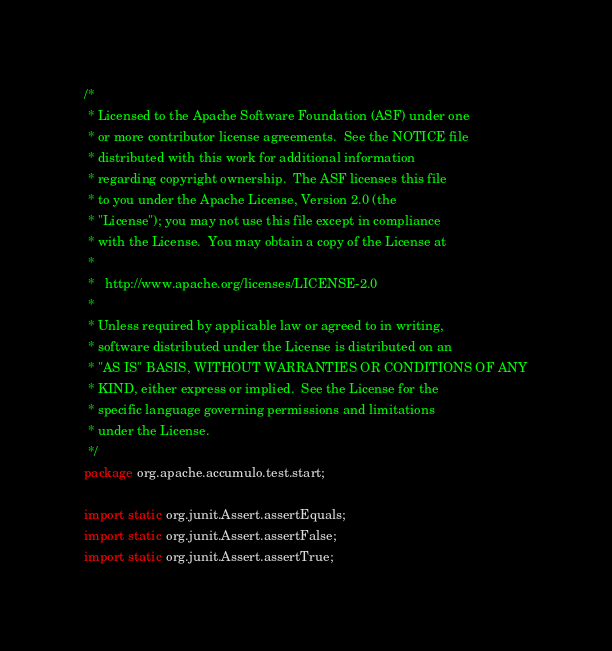<code> <loc_0><loc_0><loc_500><loc_500><_Java_>/*
 * Licensed to the Apache Software Foundation (ASF) under one
 * or more contributor license agreements.  See the NOTICE file
 * distributed with this work for additional information
 * regarding copyright ownership.  The ASF licenses this file
 * to you under the Apache License, Version 2.0 (the
 * "License"); you may not use this file except in compliance
 * with the License.  You may obtain a copy of the License at
 *
 *   http://www.apache.org/licenses/LICENSE-2.0
 *
 * Unless required by applicable law or agreed to in writing,
 * software distributed under the License is distributed on an
 * "AS IS" BASIS, WITHOUT WARRANTIES OR CONDITIONS OF ANY
 * KIND, either express or implied.  See the License for the
 * specific language governing permissions and limitations
 * under the License.
 */
package org.apache.accumulo.test.start;

import static org.junit.Assert.assertEquals;
import static org.junit.Assert.assertFalse;
import static org.junit.Assert.assertTrue;</code> 